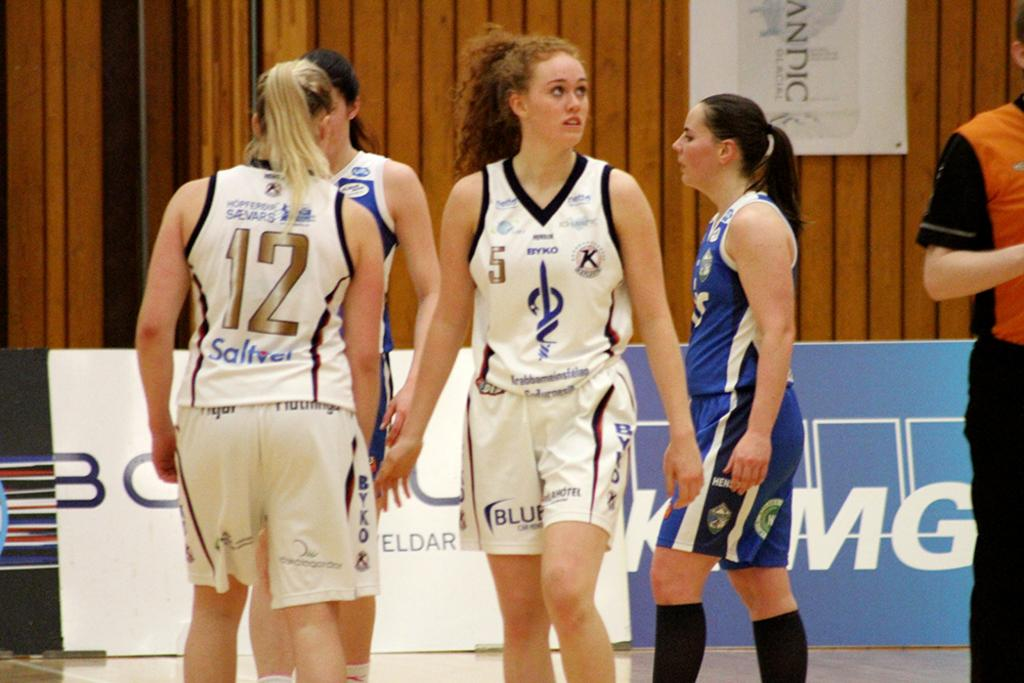<image>
Relay a brief, clear account of the picture shown. Athlete wearing a pair of shorts that says "blue" on it. 